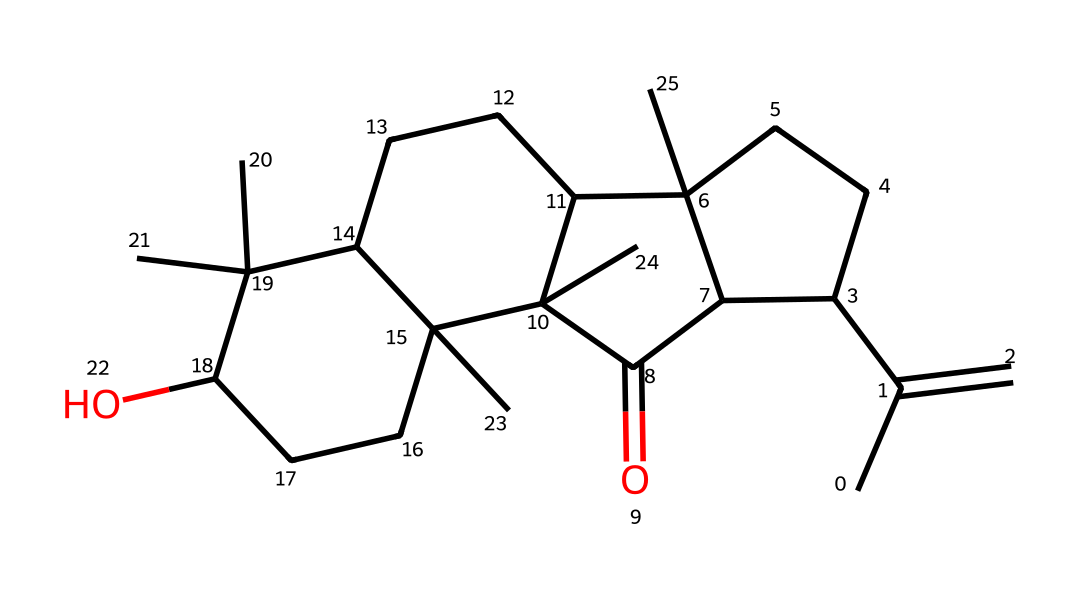What is the primary functional group in this chemical? The structure indicates a hydroxyl group (–OH) attached to an alkane, which is characteristic of alcohols. This can be determined by identifying the –OH group that is visible in the structure.
Answer: hydroxyl group How many carbon atoms are present in this chemical? Counting the carbon atoms in the provided SMILES representation shows a total of 27 carbons (C). The SMILES notation lists each carbon, including those that are part of branches or rings.
Answer: 27 What is the molecular formula of this compound? By deducing the number of carbon (C), hydrogen (H), and oxygen (O) atoms from the SMILES, we find C27H46O. The carbon and hydrogen counts take into account bonding and structure seen in the SMILES.
Answer: C27H46O Does this chemical contain any double bonds? The presence of double bonds can be identified by looking for the '=' symbol in the SMILES. Upon examination, there is one double bond present, indicating it has unsaturation.
Answer: yes What is the state of matter for this chemical at room temperature? Given the complex structure and typical compounds related to frankincense, this chemical is likely to be a solid at room temperature. This conclusion is supported by the physical state of similar natural resins.
Answer: solid What type of chemical is this, in terms of functional characteristics? The presence of the hydroxyl group and the overall structure indicate that it is a type of terpene, which are characterized by their derived natural compositions and aromatic properties.
Answer: terpene Is this chemical volatile compared to other compounds? Due to the relatively high molecular weight and the solid-state at room temperature, it suggests that it is less volatile than lighter organic compounds, which often exist as gases. The complexity also indicates lower volatility.
Answer: less volatile 